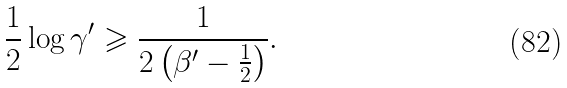Convert formula to latex. <formula><loc_0><loc_0><loc_500><loc_500>\frac { 1 } { 2 } \log \gamma ^ { \prime } \geqslant \frac { 1 } { 2 \left ( \beta ^ { \prime } - \frac { 1 } { 2 } \right ) } .</formula> 